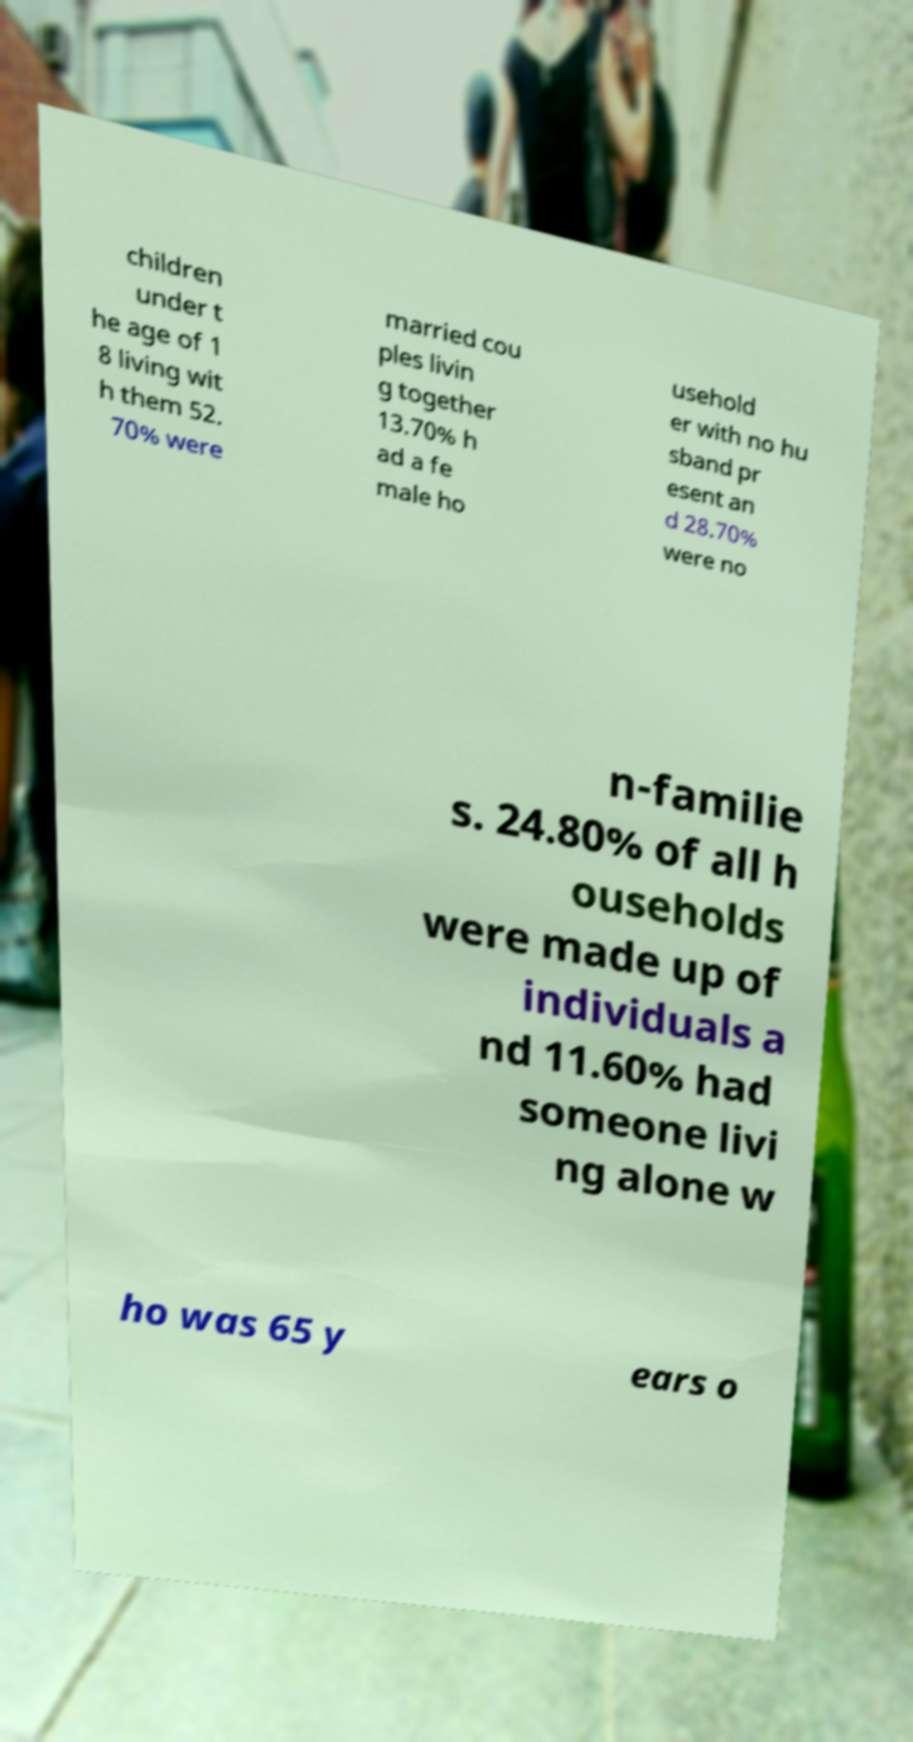Can you accurately transcribe the text from the provided image for me? children under t he age of 1 8 living wit h them 52. 70% were married cou ples livin g together 13.70% h ad a fe male ho usehold er with no hu sband pr esent an d 28.70% were no n-familie s. 24.80% of all h ouseholds were made up of individuals a nd 11.60% had someone livi ng alone w ho was 65 y ears o 